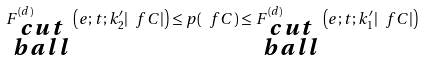Convert formula to latex. <formula><loc_0><loc_0><loc_500><loc_500>F _ { \substack { c u t \\ b a l l } } ^ { ( d ) } \left ( e ; t ; k _ { 2 } ^ { \prime } | \ f C | \right ) \leq p ( \ f C ) \leq F _ { \substack { c u t \\ b a l l } } ^ { ( d ) } \left ( e ; t ; k _ { 1 } ^ { \prime } | \ f C | \right )</formula> 